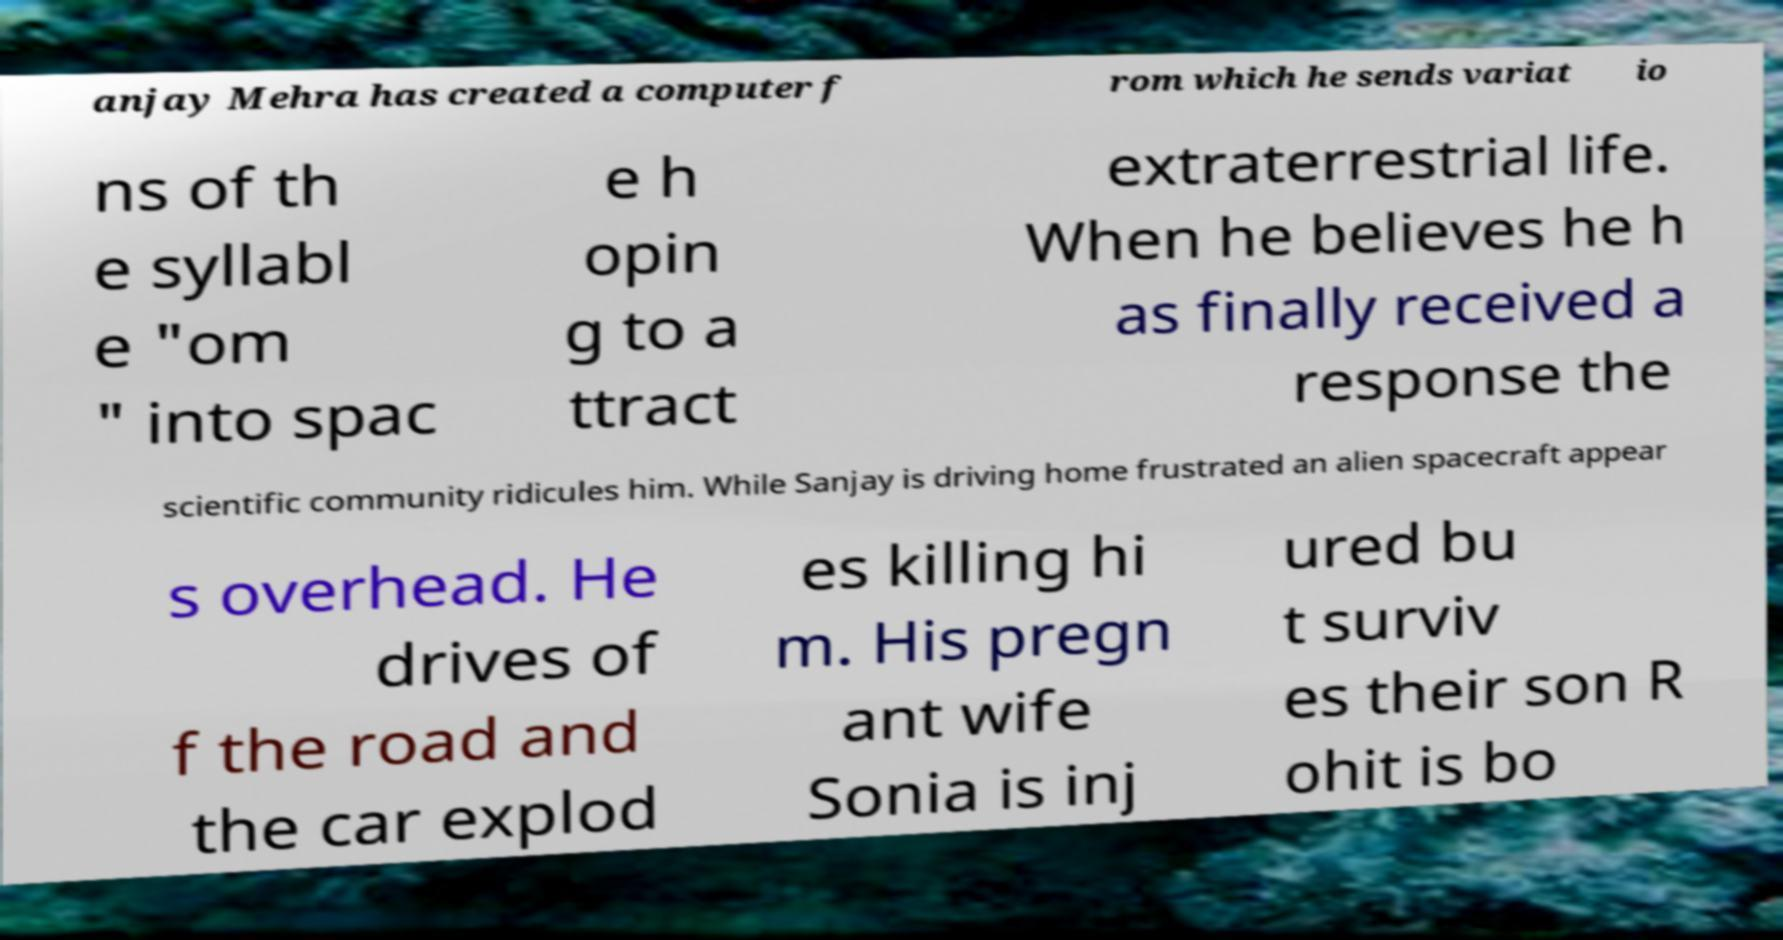Could you extract and type out the text from this image? anjay Mehra has created a computer f rom which he sends variat io ns of th e syllabl e "om " into spac e h opin g to a ttract extraterrestrial life. When he believes he h as finally received a response the scientific community ridicules him. While Sanjay is driving home frustrated an alien spacecraft appear s overhead. He drives of f the road and the car explod es killing hi m. His pregn ant wife Sonia is inj ured bu t surviv es their son R ohit is bo 